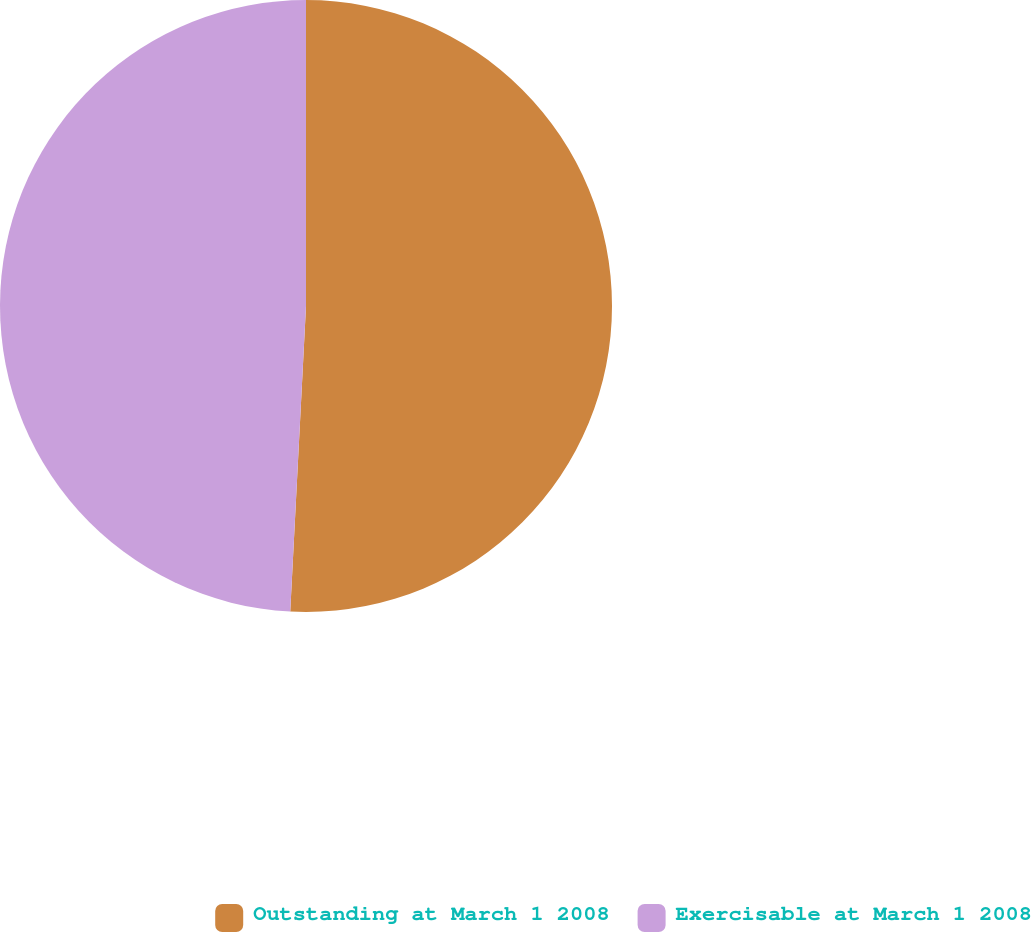Convert chart to OTSL. <chart><loc_0><loc_0><loc_500><loc_500><pie_chart><fcel>Outstanding at March 1 2008<fcel>Exercisable at March 1 2008<nl><fcel>50.82%<fcel>49.18%<nl></chart> 